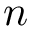<formula> <loc_0><loc_0><loc_500><loc_500>n</formula> 